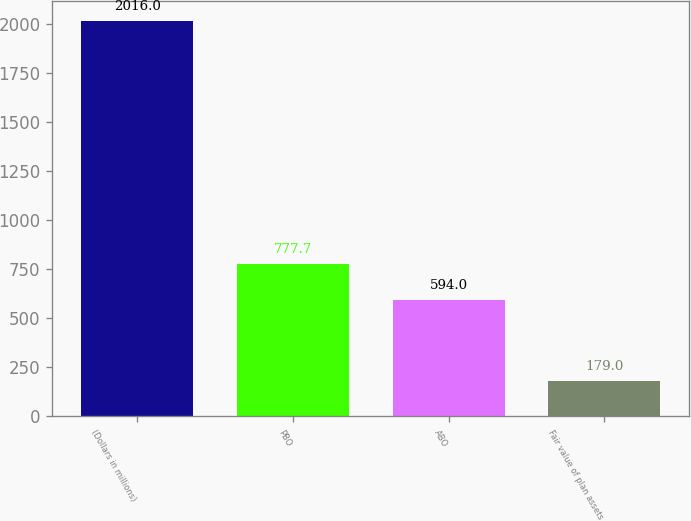Convert chart to OTSL. <chart><loc_0><loc_0><loc_500><loc_500><bar_chart><fcel>(Dollars in millions)<fcel>PBO<fcel>ABO<fcel>Fair value of plan assets<nl><fcel>2016<fcel>777.7<fcel>594<fcel>179<nl></chart> 